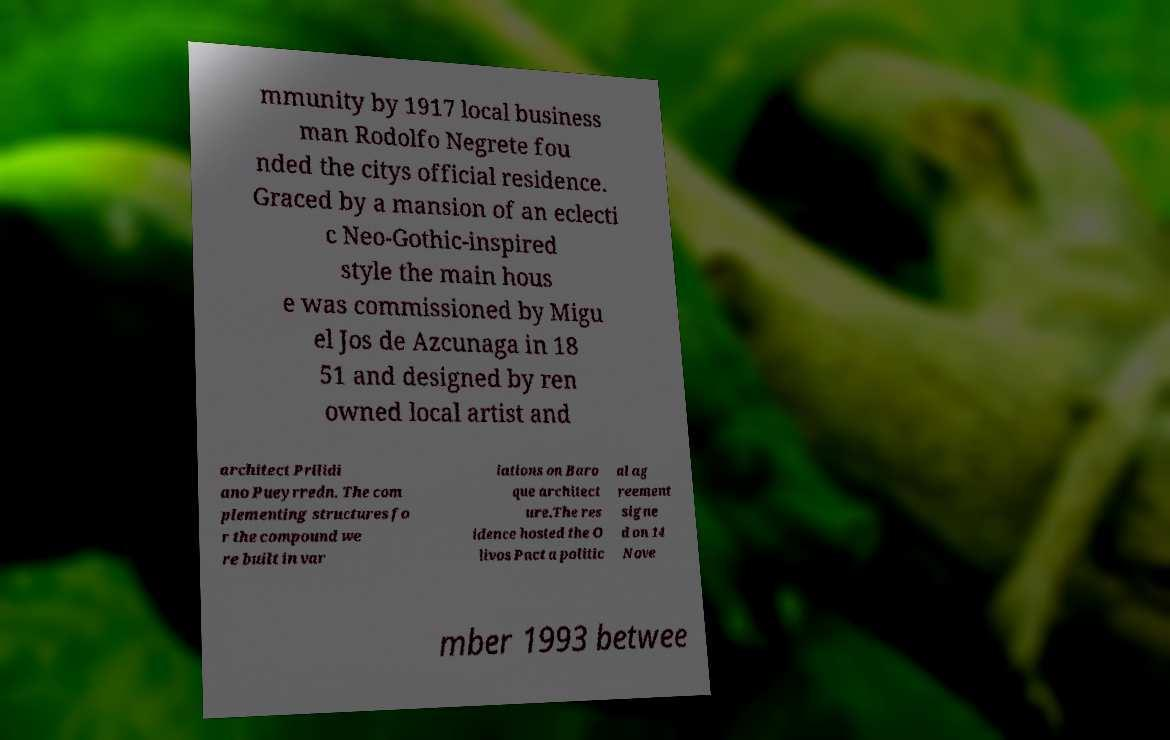Can you accurately transcribe the text from the provided image for me? mmunity by 1917 local business man Rodolfo Negrete fou nded the citys official residence. Graced by a mansion of an eclecti c Neo-Gothic-inspired style the main hous e was commissioned by Migu el Jos de Azcunaga in 18 51 and designed by ren owned local artist and architect Prilidi ano Pueyrredn. The com plementing structures fo r the compound we re built in var iations on Baro que architect ure.The res idence hosted the O livos Pact a politic al ag reement signe d on 14 Nove mber 1993 betwee 